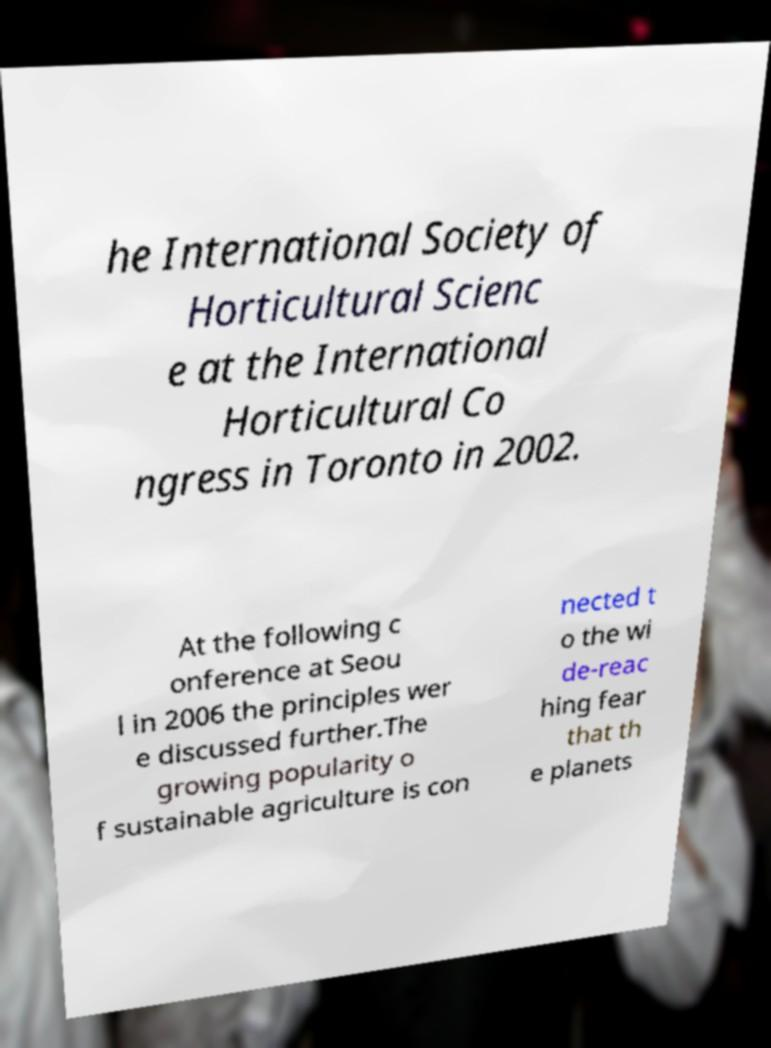I need the written content from this picture converted into text. Can you do that? he International Society of Horticultural Scienc e at the International Horticultural Co ngress in Toronto in 2002. At the following c onference at Seou l in 2006 the principles wer e discussed further.The growing popularity o f sustainable agriculture is con nected t o the wi de-reac hing fear that th e planets 